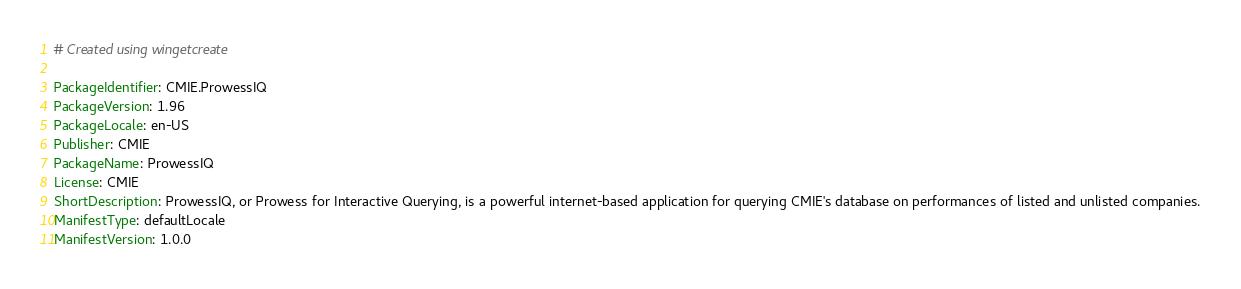<code> <loc_0><loc_0><loc_500><loc_500><_YAML_># Created using wingetcreate

PackageIdentifier: CMIE.ProwessIQ
PackageVersion: 1.96
PackageLocale: en-US
Publisher: CMIE
PackageName: ProwessIQ
License: CMIE
ShortDescription: ProwessIQ, or Prowess for Interactive Querying, is a powerful internet-based application for querying CMIE's database on performances of listed and unlisted companies.
ManifestType: defaultLocale
ManifestVersion: 1.0.0
</code> 